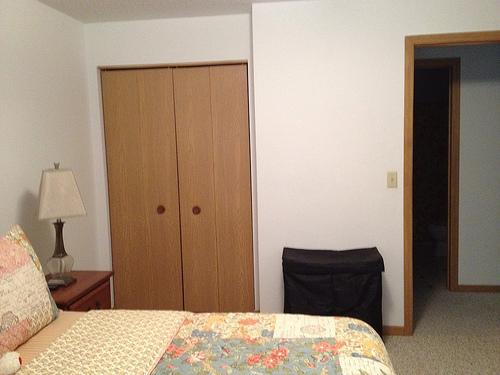Mention the key elements observed in the room and their respective positions. In the room there's a bed with flower quilt on the left, a wooden end table with a lamp on it, a wooden closet with round door handles, and a carpeted floor. Briefly describe the primary lighting situation in the bedroom. The bedroom is lit by a bedside lamp with a white lampshade, placed on a wooden end table near the bed. Enumerate the primary elements that make up the bedroom ambiance in the image. Comfortable bed, quilt with flower pattern, pillow, wooden end table with a lamp, wood closet doors, round door handles, and carpeted floor. Provide a brief summary of the room's layout and furnishings. The room consists of a large bed with a quilt and pillow, wooden end table and double wood closet doors, carpeted floor, and laundry hamper. Provide a concise description of the bedroom scene in the image. A cozy bedroom with a bed featuring flower quilt and pillow, wooden end table with bedside lamp, carpeted floor, and double closet doors with round knobs. Mention the critical features of the room and describe their characteristics. In the room we have a bed with flower quilt, pillow, wooden end table holding a lamp with white shade, wooden closet doors with round handles, and a grey carpeted floor. Enumerate the visible furniture and accessories seen in the bedroom. Bed, flower quilt, pillow, wooden end table, bedside lamp, wood closet doors, door knobs, carpeted floor, laundry hamper, and light switch. Describe the primary focal point of the image and mention a few accompanying details. The main focus is the bed with flower quilt and pillow, accompanied by a nearby wooden end table with a lamp and wood closet doors with round handles. List the notable objects present in the bedroom scene. Bed, flower quilt, pillow, wooden end table, lamp with white lampshade, double wood closet doors, round door handles, carpeted floor, laundry hamper. Write a sentence highlighting the main objects seen in the picture. The bedroom scene features a comfortable bed with flower quilt, pillow, an end table with lamp, and wooden closet doors with round handles. 